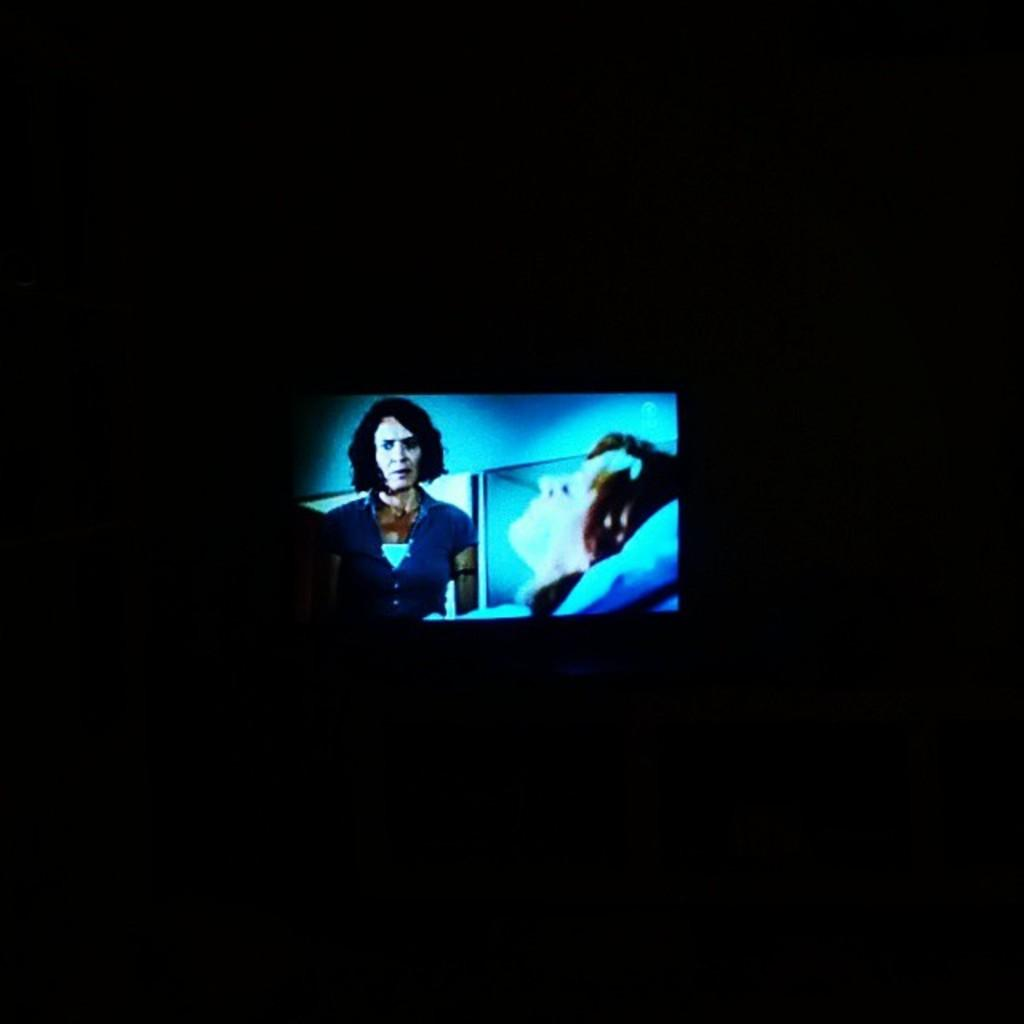What is the main object in the image? There is a display screen present in the image. What can be seen on the display screen? There are two persons visible on the display screen. What color is the background of the image? The background of the image is black. Can you tell me how many robins are sitting on the display screen? There are no robins present on the display screen; it features two persons. What type of force is being applied to the persons on the display screen? There is no indication of any force being applied to the persons on the display screen; they are simply visible on the screen. 